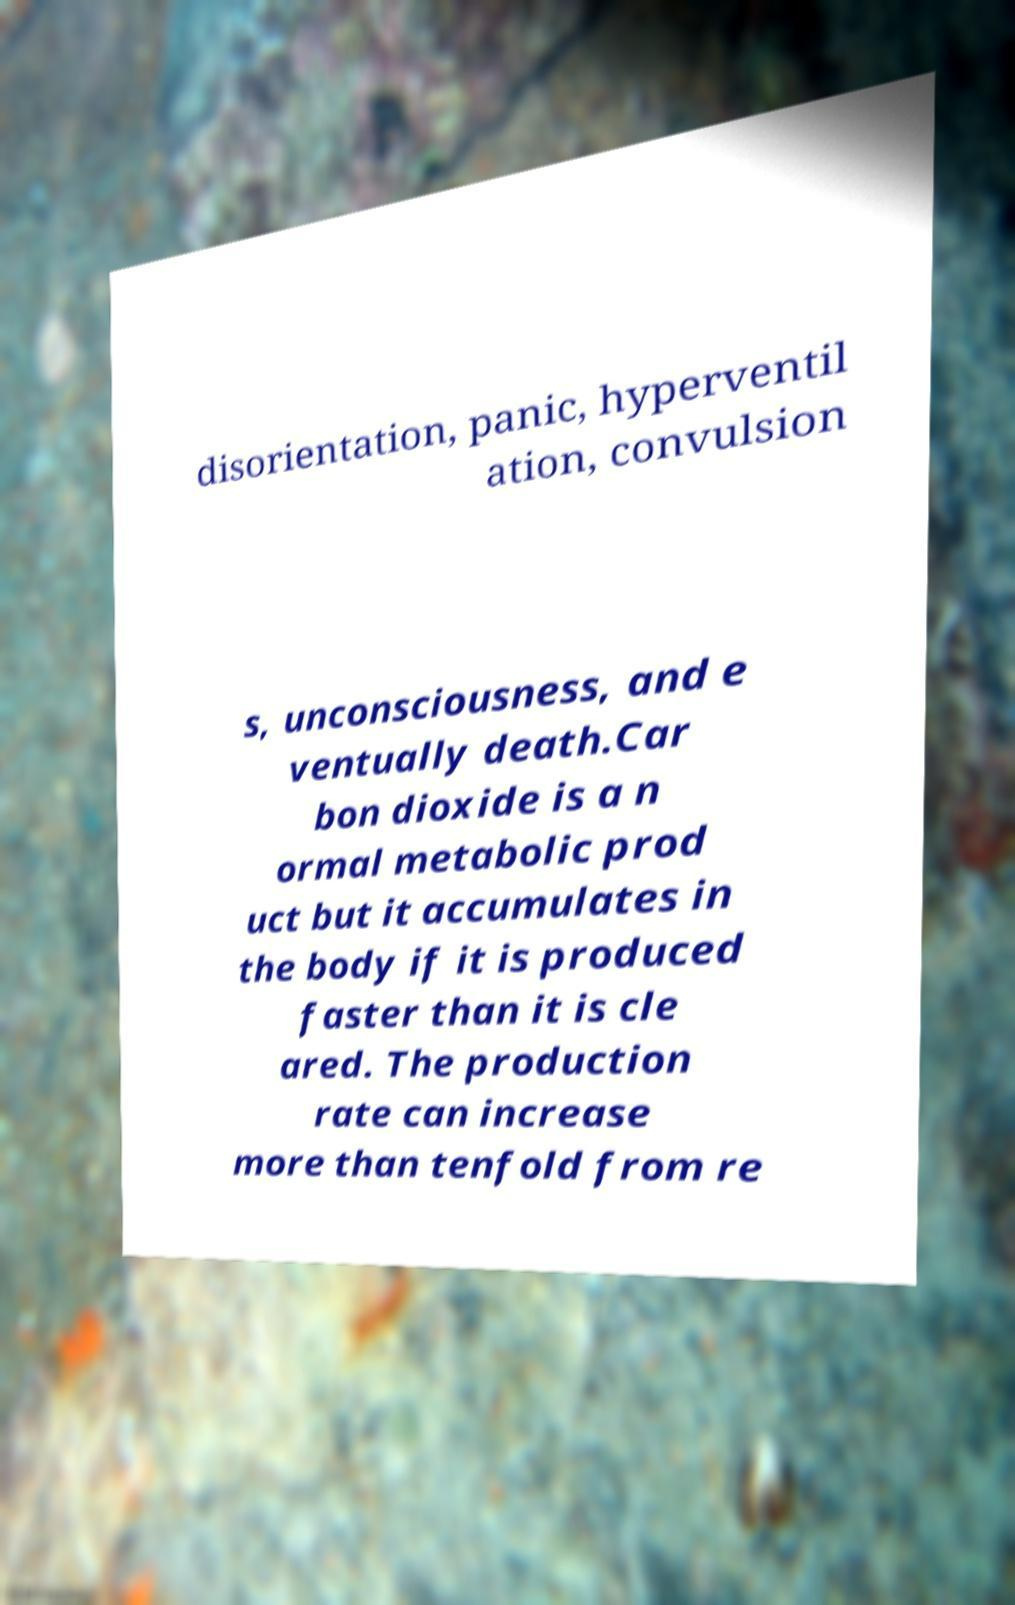For documentation purposes, I need the text within this image transcribed. Could you provide that? disorientation, panic, hyperventil ation, convulsion s, unconsciousness, and e ventually death.Car bon dioxide is a n ormal metabolic prod uct but it accumulates in the body if it is produced faster than it is cle ared. The production rate can increase more than tenfold from re 